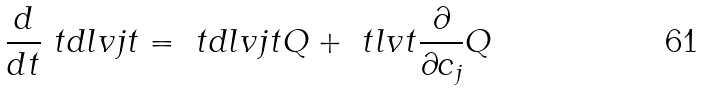Convert formula to latex. <formula><loc_0><loc_0><loc_500><loc_500>\frac { d } { d t } \ t d l v { j } { t } = \ t d l v { j } { t } Q + \ t l v { t } \frac { \partial } { \partial c _ { j } } Q</formula> 